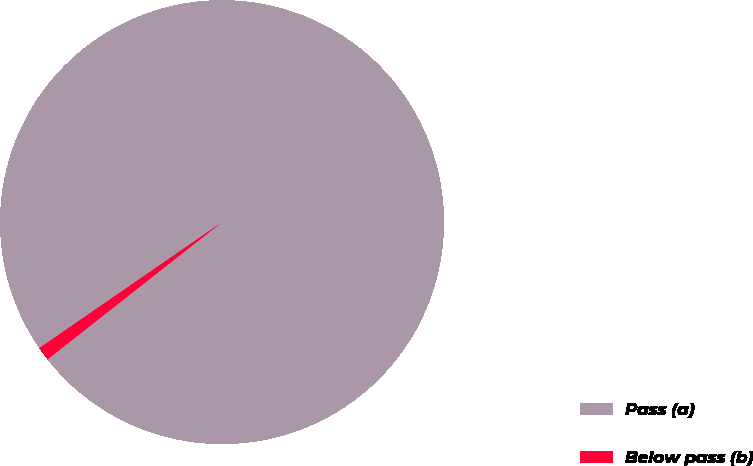<chart> <loc_0><loc_0><loc_500><loc_500><pie_chart><fcel>Pass (a)<fcel>Below pass (b)<nl><fcel>99.0%<fcel>1.0%<nl></chart> 